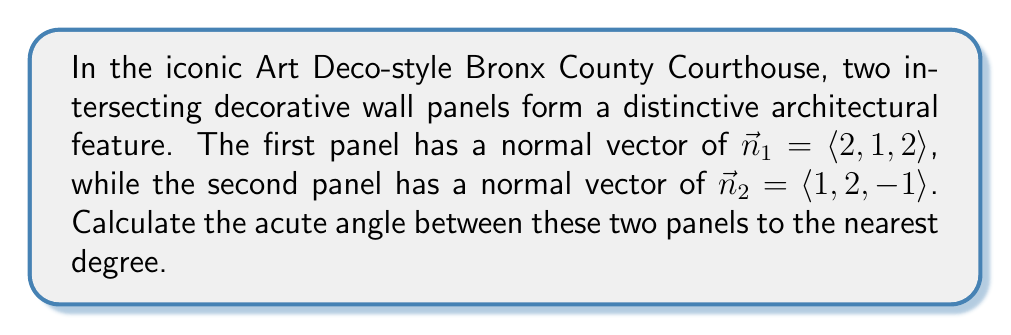Show me your answer to this math problem. To find the angle between two planes, we can use the angle between their normal vectors. The formula for the angle $\theta$ between two vectors $\vec{a}$ and $\vec{b}$ is:

$$\cos \theta = \frac{\vec{a} \cdot \vec{b}}{|\vec{a}||\vec{b}|}$$

Where $\vec{a} \cdot \vec{b}$ is the dot product and $|\vec{a}|$ and $|\vec{b}|$ are the magnitudes of the vectors.

Step 1: Calculate the dot product of $\vec{n}_1$ and $\vec{n}_2$:
$$\vec{n}_1 \cdot \vec{n}_2 = (2)(1) + (1)(2) + (2)(-1) = 2 + 2 - 2 = 2$$

Step 2: Calculate the magnitudes of $\vec{n}_1$ and $\vec{n}_2$:
$$|\vec{n}_1| = \sqrt{2^2 + 1^2 + 2^2} = \sqrt{9} = 3$$
$$|\vec{n}_2| = \sqrt{1^2 + 2^2 + (-1)^2} = \sqrt{6}$$

Step 3: Substitute into the formula:
$$\cos \theta = \frac{2}{3\sqrt{6}}$$

Step 4: Take the inverse cosine (arccos) of both sides:
$$\theta = \arccos\left(\frac{2}{3\sqrt{6}}\right)$$

Step 5: Calculate the result and round to the nearest degree:
$$\theta \approx 75^\circ$$
Answer: $75^\circ$ 